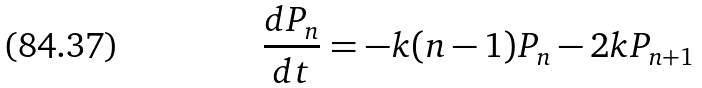Convert formula to latex. <formula><loc_0><loc_0><loc_500><loc_500>\frac { d P _ { n } } { d t } = - k ( n - 1 ) P _ { n } - 2 k P _ { n + 1 }</formula> 